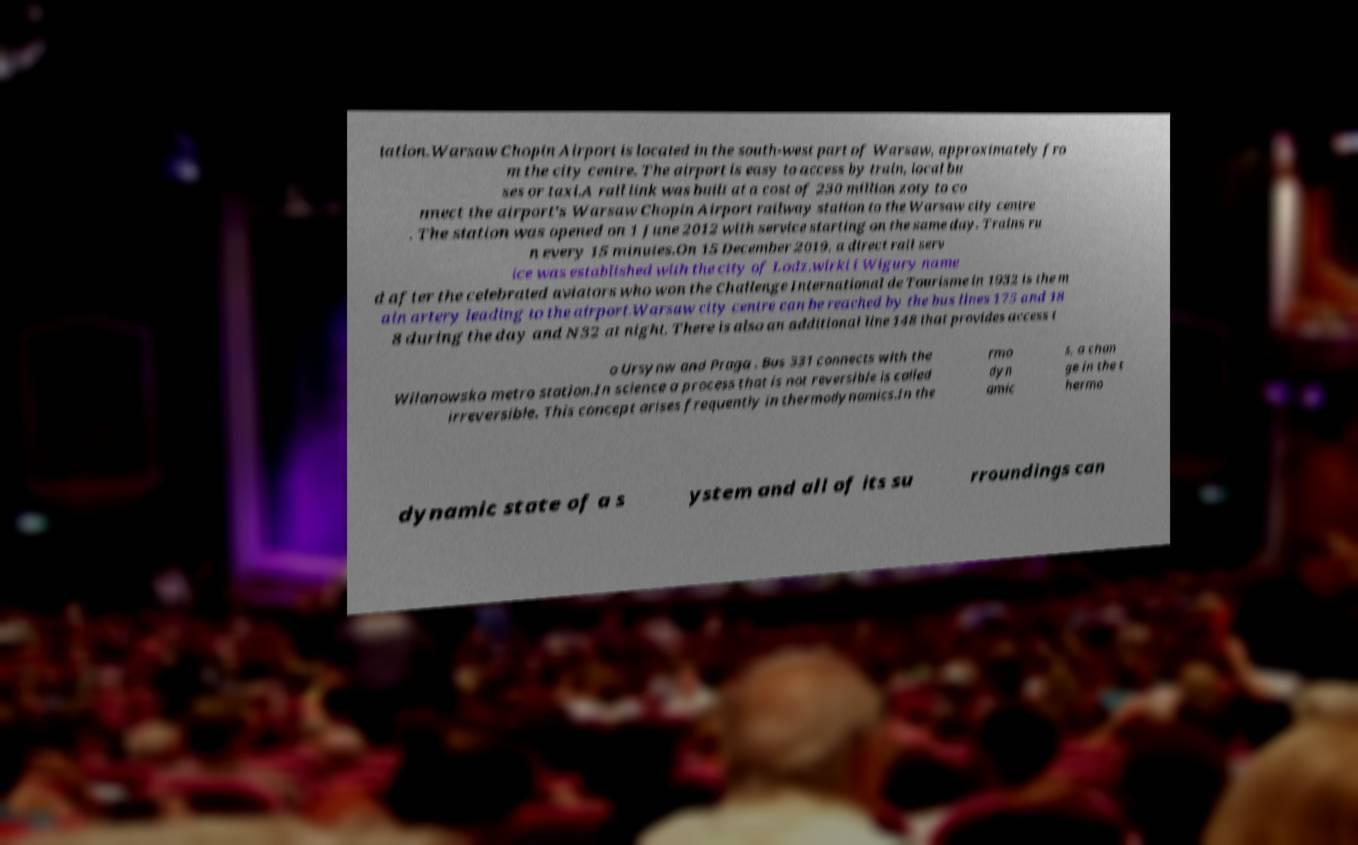Can you accurately transcribe the text from the provided image for me? tation.Warsaw Chopin Airport is located in the south-west part of Warsaw, approximately fro m the city centre. The airport is easy to access by train, local bu ses or taxi.A rail link was built at a cost of 230 million zoty to co nnect the airport's Warsaw Chopin Airport railway station to the Warsaw city centre . The station was opened on 1 June 2012 with service starting on the same day. Trains ru n every 15 minutes.On 15 December 2019, a direct rail serv ice was established with the city of Lodz.wirki i Wigury name d after the celebrated aviators who won the Challenge International de Tourisme in 1932 is the m ain artery leading to the airport.Warsaw city centre can be reached by the bus lines 175 and 18 8 during the day and N32 at night. There is also an additional line 148 that provides access t o Ursynw and Praga . Bus 331 connects with the Wilanowska metro station.In science a process that is not reversible is called irreversible. This concept arises frequently in thermodynamics.In the rmo dyn amic s, a chan ge in the t hermo dynamic state of a s ystem and all of its su rroundings can 